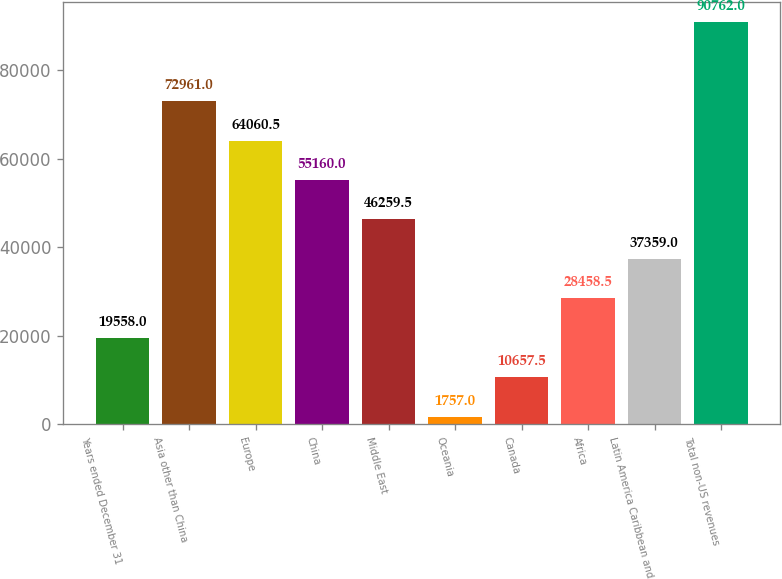Convert chart to OTSL. <chart><loc_0><loc_0><loc_500><loc_500><bar_chart><fcel>Years ended December 31<fcel>Asia other than China<fcel>Europe<fcel>China<fcel>Middle East<fcel>Oceania<fcel>Canada<fcel>Africa<fcel>Latin America Caribbean and<fcel>Total non-US revenues<nl><fcel>19558<fcel>72961<fcel>64060.5<fcel>55160<fcel>46259.5<fcel>1757<fcel>10657.5<fcel>28458.5<fcel>37359<fcel>90762<nl></chart> 